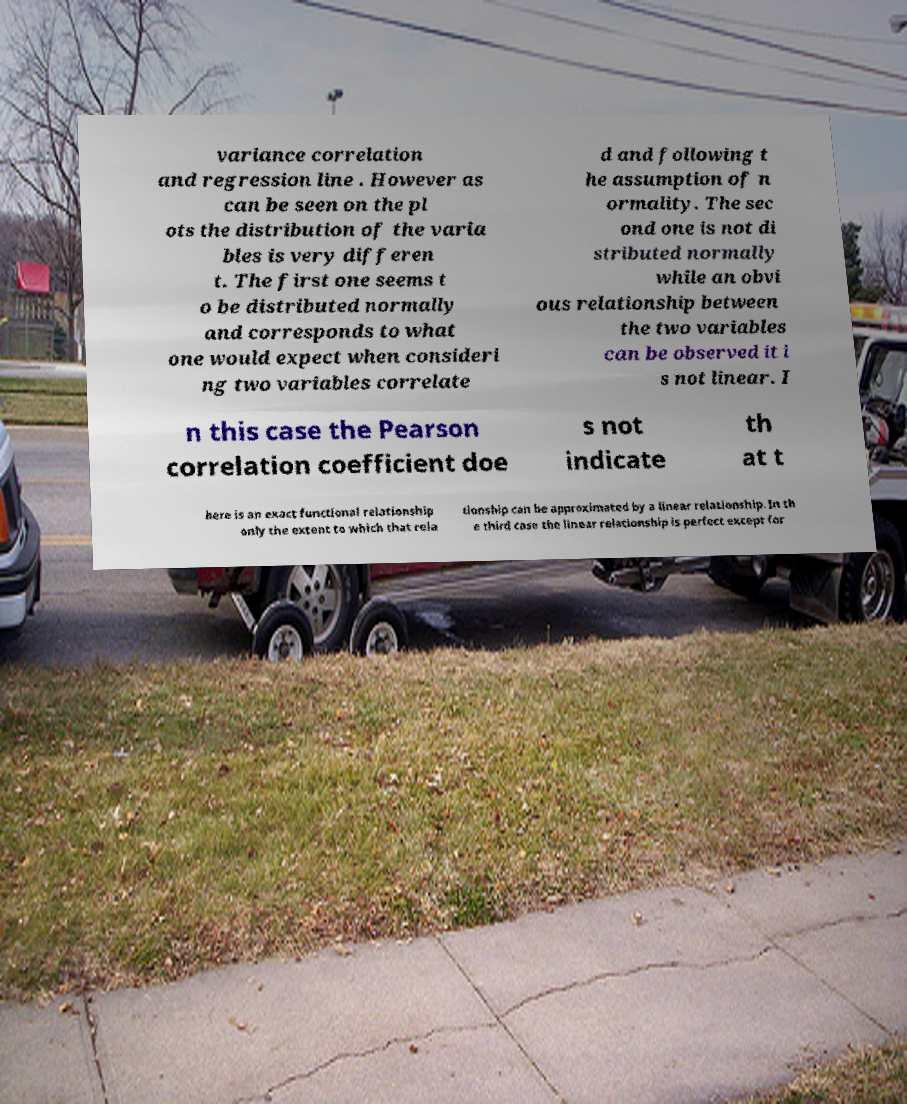Please read and relay the text visible in this image. What does it say? variance correlation and regression line . However as can be seen on the pl ots the distribution of the varia bles is very differen t. The first one seems t o be distributed normally and corresponds to what one would expect when consideri ng two variables correlate d and following t he assumption of n ormality. The sec ond one is not di stributed normally while an obvi ous relationship between the two variables can be observed it i s not linear. I n this case the Pearson correlation coefficient doe s not indicate th at t here is an exact functional relationship only the extent to which that rela tionship can be approximated by a linear relationship. In th e third case the linear relationship is perfect except for 